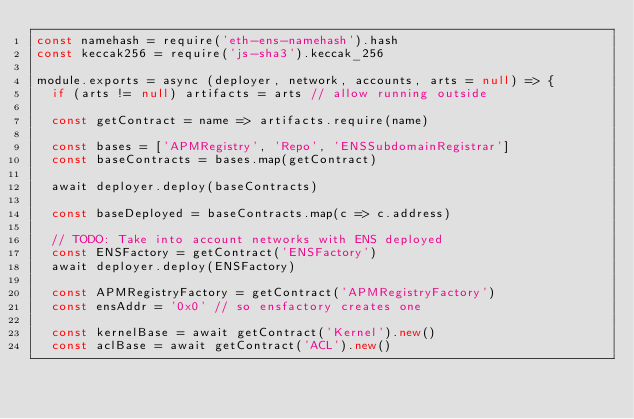<code> <loc_0><loc_0><loc_500><loc_500><_JavaScript_>const namehash = require('eth-ens-namehash').hash
const keccak256 = require('js-sha3').keccak_256

module.exports = async (deployer, network, accounts, arts = null) => {
  if (arts != null) artifacts = arts // allow running outside

  const getContract = name => artifacts.require(name)

  const bases = ['APMRegistry', 'Repo', 'ENSSubdomainRegistrar']
  const baseContracts = bases.map(getContract)

  await deployer.deploy(baseContracts)

  const baseDeployed = baseContracts.map(c => c.address)

  // TODO: Take into account networks with ENS deployed
  const ENSFactory = getContract('ENSFactory')
  await deployer.deploy(ENSFactory)

  const APMRegistryFactory = getContract('APMRegistryFactory')
  const ensAddr = '0x0' // so ensfactory creates one

  const kernelBase = await getContract('Kernel').new()
  const aclBase = await getContract('ACL').new()</code> 